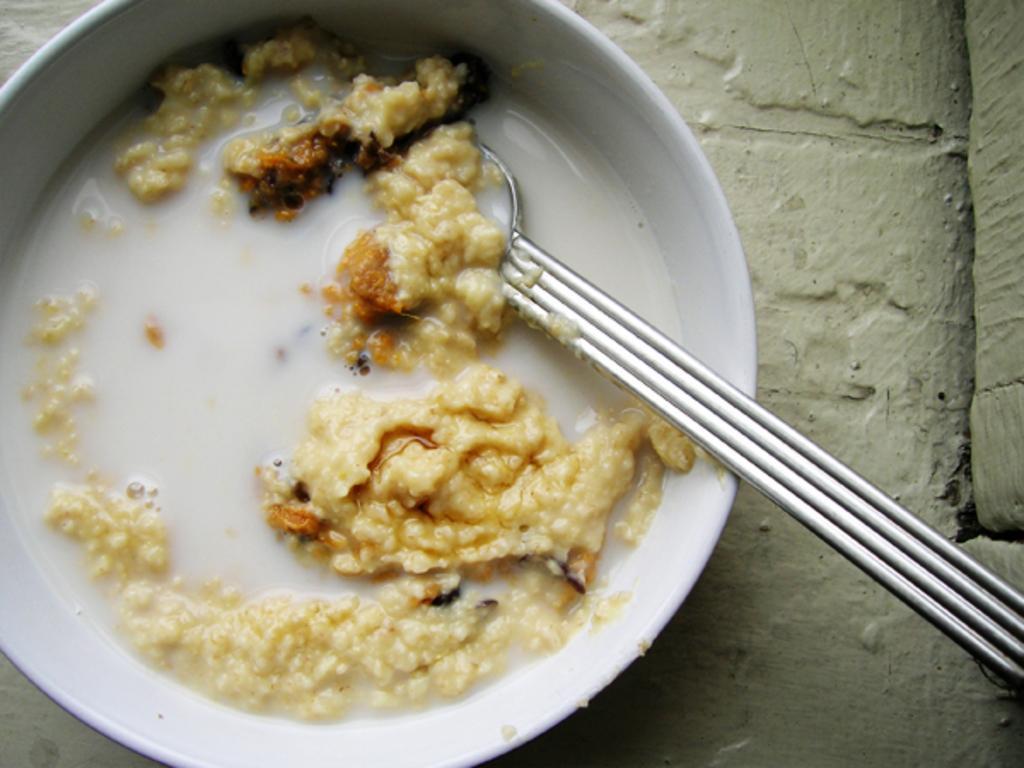Could you give a brief overview of what you see in this image? In this image there is a food item with a spoon in a bowl on a concrete surface. 